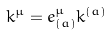Convert formula to latex. <formula><loc_0><loc_0><loc_500><loc_500>k ^ { \mu } = e ^ { \mu } _ { ( a ) } k ^ { ( a ) }</formula> 